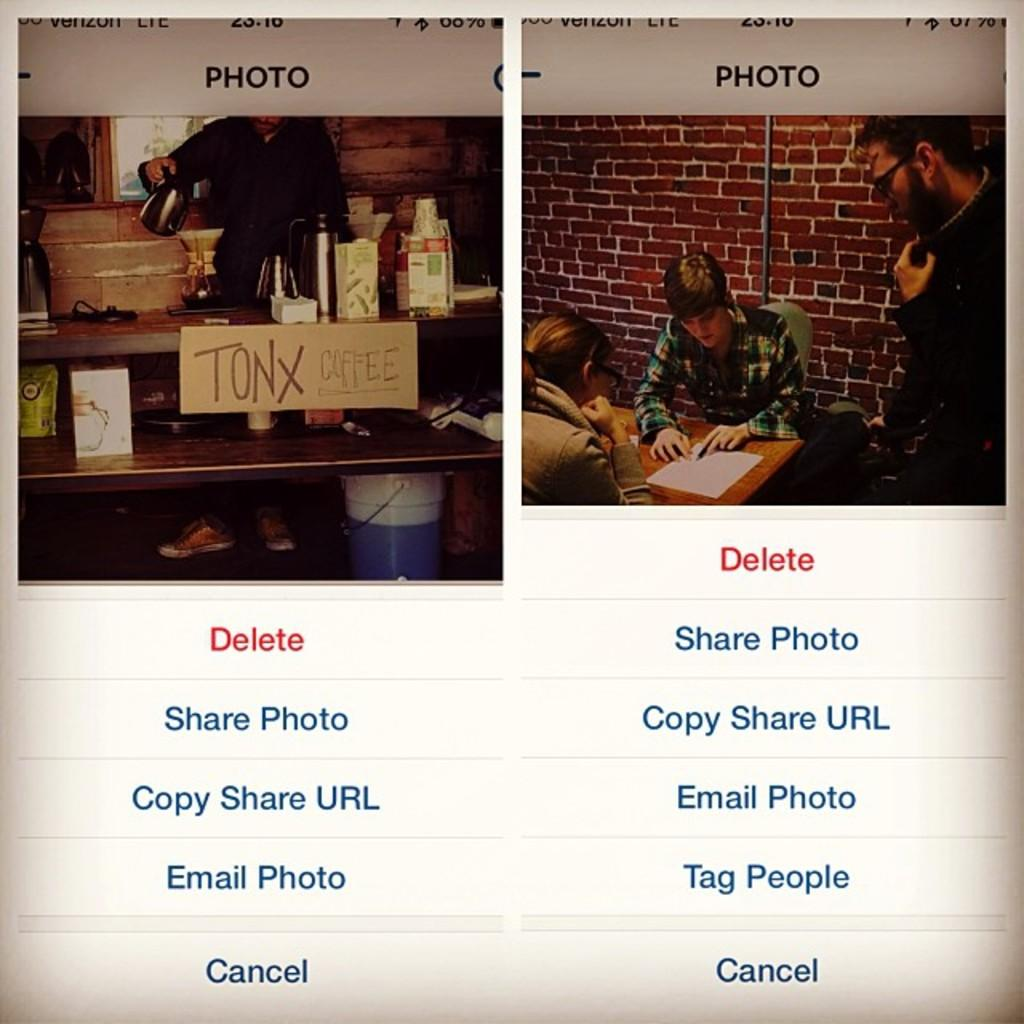<image>
Present a compact description of the photo's key features. Two photos of people doing different things and words below the photo including the word delete. 